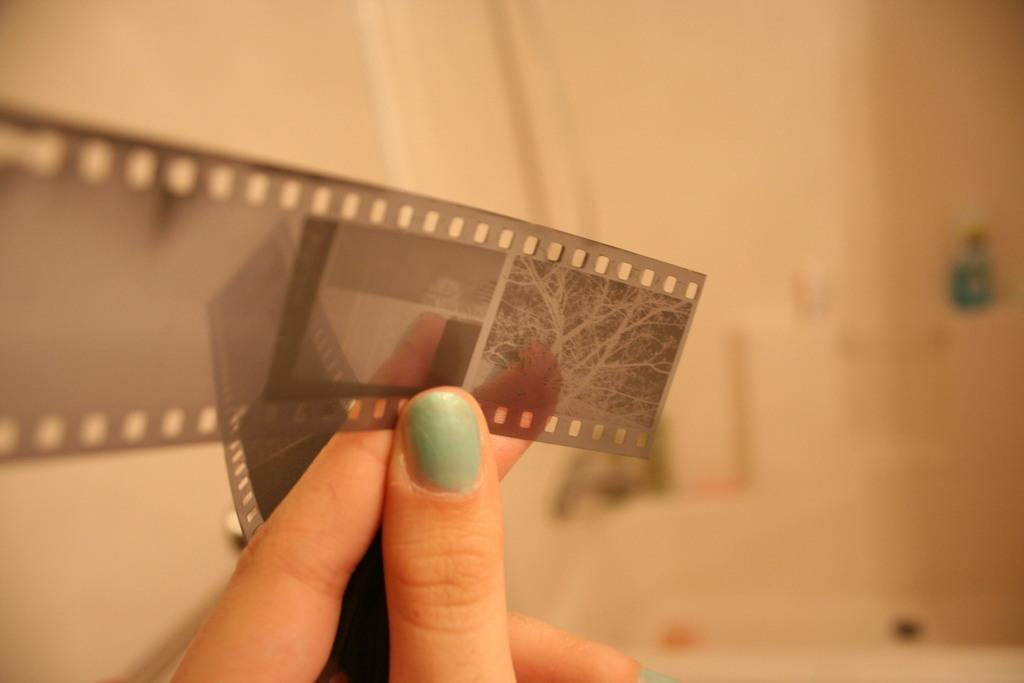What is the main subject of the image? There is a person in the image. What is the person holding in her fingers? The person is holding a negative film reel in her fingers. What type of collar can be seen on the wall in the image? There is no collar present in the image, nor is there a wall visible. 